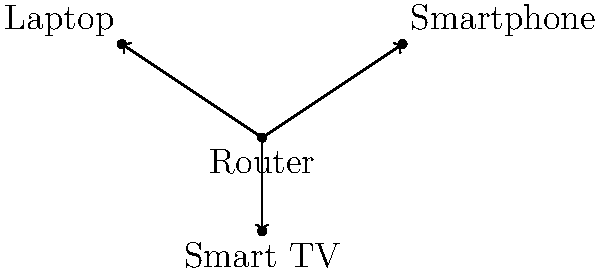In a typical home network setup, which device serves as the central point of connection for all other devices? To answer this question, let's consider the basic structure of a home network:

1. The central device in a home network is typically the router.
2. The router acts as a hub, connecting all other devices to the internet and to each other.
3. In the diagram, we can see that the router is at the center, with lines connecting it to other devices.
4. These other devices (laptop, smartphone, and smart TV) are all connected directly to the router.
5. The router manages the flow of data between these devices and the internet.
6. It assigns local IP addresses to each device and directs internet traffic to and from them.
7. This star-like topology, with the router at the center, is the most common setup for home networks.

Therefore, the device that serves as the central point of connection in a typical home network is the router.
Answer: Router 